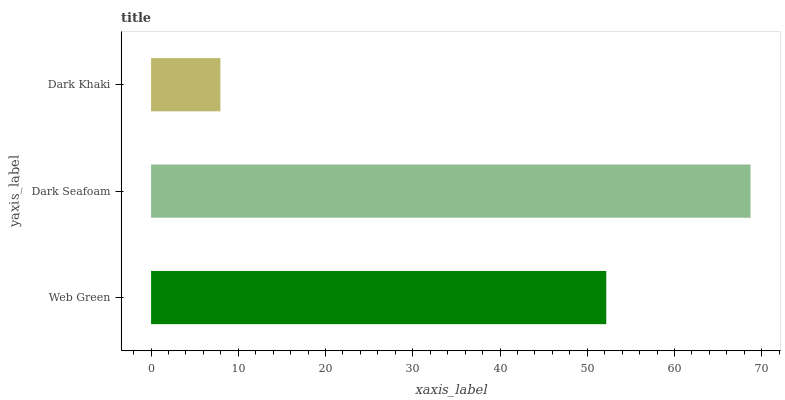Is Dark Khaki the minimum?
Answer yes or no. Yes. Is Dark Seafoam the maximum?
Answer yes or no. Yes. Is Dark Seafoam the minimum?
Answer yes or no. No. Is Dark Khaki the maximum?
Answer yes or no. No. Is Dark Seafoam greater than Dark Khaki?
Answer yes or no. Yes. Is Dark Khaki less than Dark Seafoam?
Answer yes or no. Yes. Is Dark Khaki greater than Dark Seafoam?
Answer yes or no. No. Is Dark Seafoam less than Dark Khaki?
Answer yes or no. No. Is Web Green the high median?
Answer yes or no. Yes. Is Web Green the low median?
Answer yes or no. Yes. Is Dark Khaki the high median?
Answer yes or no. No. Is Dark Seafoam the low median?
Answer yes or no. No. 